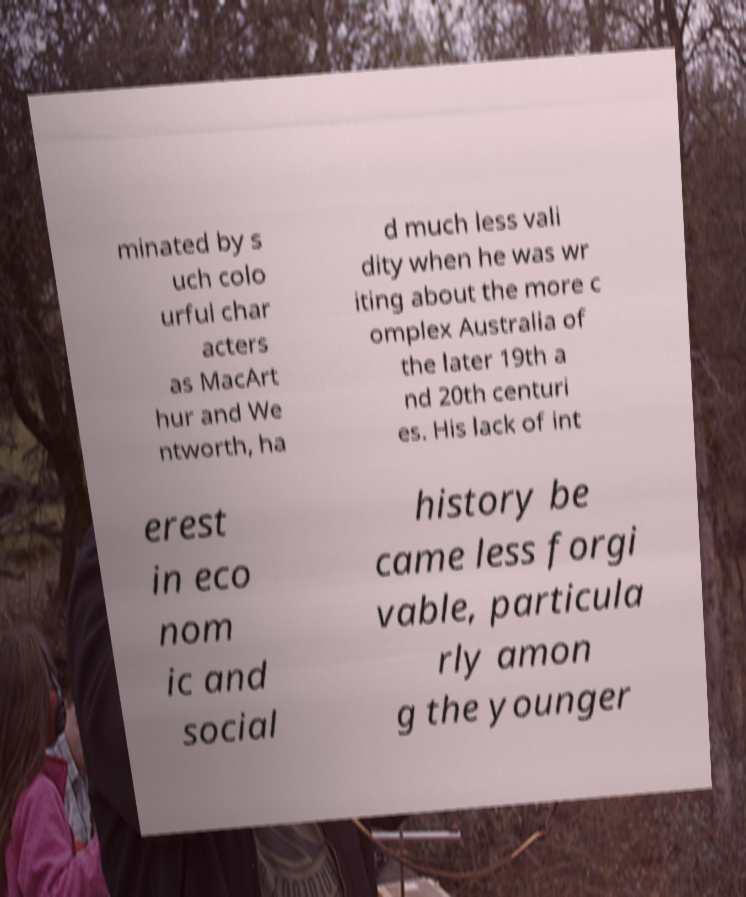Can you accurately transcribe the text from the provided image for me? minated by s uch colo urful char acters as MacArt hur and We ntworth, ha d much less vali dity when he was wr iting about the more c omplex Australia of the later 19th a nd 20th centuri es. His lack of int erest in eco nom ic and social history be came less forgi vable, particula rly amon g the younger 